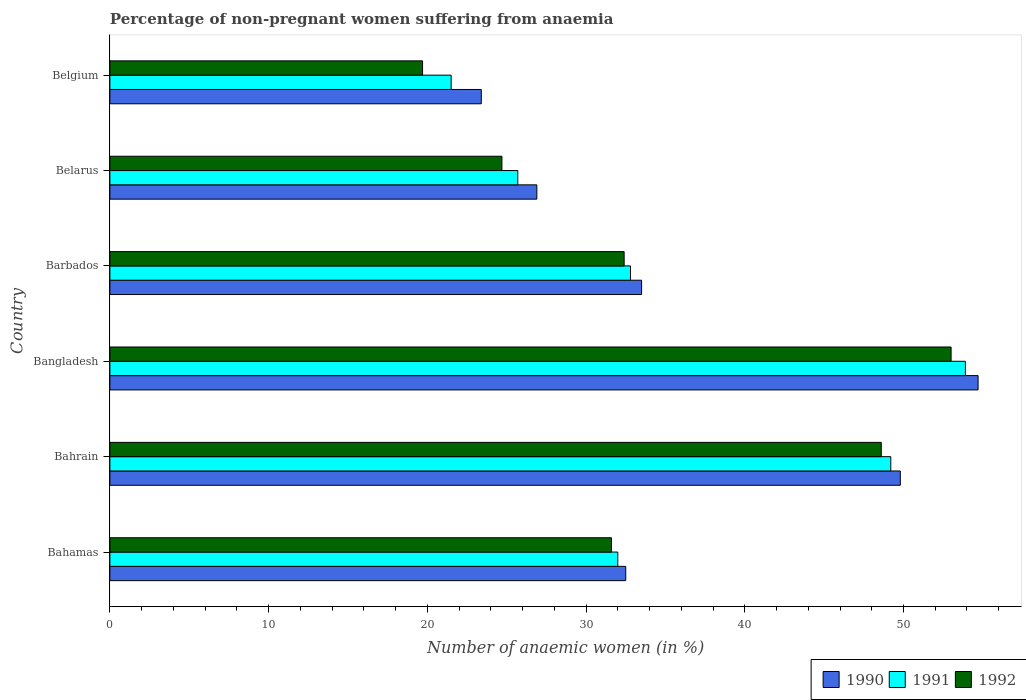How many groups of bars are there?
Keep it short and to the point. 6. Are the number of bars per tick equal to the number of legend labels?
Your response must be concise. Yes. How many bars are there on the 4th tick from the bottom?
Offer a terse response. 3. In how many cases, is the number of bars for a given country not equal to the number of legend labels?
Provide a short and direct response. 0. What is the percentage of non-pregnant women suffering from anaemia in 1990 in Bahamas?
Provide a short and direct response. 32.5. Across all countries, what is the maximum percentage of non-pregnant women suffering from anaemia in 1991?
Give a very brief answer. 53.9. Across all countries, what is the minimum percentage of non-pregnant women suffering from anaemia in 1991?
Make the answer very short. 21.5. In which country was the percentage of non-pregnant women suffering from anaemia in 1990 maximum?
Your answer should be compact. Bangladesh. What is the total percentage of non-pregnant women suffering from anaemia in 1990 in the graph?
Give a very brief answer. 220.8. What is the difference between the percentage of non-pregnant women suffering from anaemia in 1991 in Bahamas and that in Belgium?
Your answer should be very brief. 10.5. What is the average percentage of non-pregnant women suffering from anaemia in 1990 per country?
Give a very brief answer. 36.8. What is the difference between the percentage of non-pregnant women suffering from anaemia in 1992 and percentage of non-pregnant women suffering from anaemia in 1991 in Belgium?
Make the answer very short. -1.8. In how many countries, is the percentage of non-pregnant women suffering from anaemia in 1991 greater than 12 %?
Offer a very short reply. 6. What is the ratio of the percentage of non-pregnant women suffering from anaemia in 1990 in Barbados to that in Belgium?
Give a very brief answer. 1.43. Is the percentage of non-pregnant women suffering from anaemia in 1992 in Bahrain less than that in Belgium?
Offer a very short reply. No. What is the difference between the highest and the second highest percentage of non-pregnant women suffering from anaemia in 1991?
Keep it short and to the point. 4.7. What is the difference between the highest and the lowest percentage of non-pregnant women suffering from anaemia in 1991?
Keep it short and to the point. 32.4. How many countries are there in the graph?
Make the answer very short. 6. What is the difference between two consecutive major ticks on the X-axis?
Keep it short and to the point. 10. Does the graph contain any zero values?
Your answer should be very brief. No. Where does the legend appear in the graph?
Your response must be concise. Bottom right. What is the title of the graph?
Your response must be concise. Percentage of non-pregnant women suffering from anaemia. Does "1994" appear as one of the legend labels in the graph?
Your response must be concise. No. What is the label or title of the X-axis?
Offer a very short reply. Number of anaemic women (in %). What is the Number of anaemic women (in %) of 1990 in Bahamas?
Make the answer very short. 32.5. What is the Number of anaemic women (in %) in 1991 in Bahamas?
Ensure brevity in your answer.  32. What is the Number of anaemic women (in %) of 1992 in Bahamas?
Provide a succinct answer. 31.6. What is the Number of anaemic women (in %) of 1990 in Bahrain?
Offer a terse response. 49.8. What is the Number of anaemic women (in %) of 1991 in Bahrain?
Ensure brevity in your answer.  49.2. What is the Number of anaemic women (in %) of 1992 in Bahrain?
Your response must be concise. 48.6. What is the Number of anaemic women (in %) in 1990 in Bangladesh?
Your response must be concise. 54.7. What is the Number of anaemic women (in %) of 1991 in Bangladesh?
Your answer should be compact. 53.9. What is the Number of anaemic women (in %) in 1990 in Barbados?
Provide a succinct answer. 33.5. What is the Number of anaemic women (in %) in 1991 in Barbados?
Your answer should be very brief. 32.8. What is the Number of anaemic women (in %) of 1992 in Barbados?
Your response must be concise. 32.4. What is the Number of anaemic women (in %) in 1990 in Belarus?
Offer a very short reply. 26.9. What is the Number of anaemic women (in %) of 1991 in Belarus?
Provide a succinct answer. 25.7. What is the Number of anaemic women (in %) in 1992 in Belarus?
Offer a terse response. 24.7. What is the Number of anaemic women (in %) of 1990 in Belgium?
Give a very brief answer. 23.4. What is the Number of anaemic women (in %) in 1991 in Belgium?
Your answer should be compact. 21.5. Across all countries, what is the maximum Number of anaemic women (in %) in 1990?
Offer a terse response. 54.7. Across all countries, what is the maximum Number of anaemic women (in %) of 1991?
Your response must be concise. 53.9. Across all countries, what is the minimum Number of anaemic women (in %) in 1990?
Your answer should be very brief. 23.4. Across all countries, what is the minimum Number of anaemic women (in %) in 1991?
Provide a short and direct response. 21.5. What is the total Number of anaemic women (in %) of 1990 in the graph?
Provide a succinct answer. 220.8. What is the total Number of anaemic women (in %) of 1991 in the graph?
Offer a very short reply. 215.1. What is the total Number of anaemic women (in %) in 1992 in the graph?
Offer a very short reply. 210. What is the difference between the Number of anaemic women (in %) in 1990 in Bahamas and that in Bahrain?
Offer a very short reply. -17.3. What is the difference between the Number of anaemic women (in %) in 1991 in Bahamas and that in Bahrain?
Ensure brevity in your answer.  -17.2. What is the difference between the Number of anaemic women (in %) of 1990 in Bahamas and that in Bangladesh?
Offer a terse response. -22.2. What is the difference between the Number of anaemic women (in %) of 1991 in Bahamas and that in Bangladesh?
Give a very brief answer. -21.9. What is the difference between the Number of anaemic women (in %) in 1992 in Bahamas and that in Bangladesh?
Offer a terse response. -21.4. What is the difference between the Number of anaemic women (in %) in 1990 in Bahamas and that in Barbados?
Give a very brief answer. -1. What is the difference between the Number of anaemic women (in %) in 1992 in Bahamas and that in Barbados?
Your answer should be compact. -0.8. What is the difference between the Number of anaemic women (in %) in 1990 in Bahamas and that in Belgium?
Provide a short and direct response. 9.1. What is the difference between the Number of anaemic women (in %) in 1991 in Bahamas and that in Belgium?
Make the answer very short. 10.5. What is the difference between the Number of anaemic women (in %) in 1990 in Bahrain and that in Bangladesh?
Your response must be concise. -4.9. What is the difference between the Number of anaemic women (in %) of 1991 in Bahrain and that in Bangladesh?
Keep it short and to the point. -4.7. What is the difference between the Number of anaemic women (in %) of 1992 in Bahrain and that in Bangladesh?
Give a very brief answer. -4.4. What is the difference between the Number of anaemic women (in %) in 1990 in Bahrain and that in Belarus?
Ensure brevity in your answer.  22.9. What is the difference between the Number of anaemic women (in %) of 1992 in Bahrain and that in Belarus?
Provide a succinct answer. 23.9. What is the difference between the Number of anaemic women (in %) of 1990 in Bahrain and that in Belgium?
Ensure brevity in your answer.  26.4. What is the difference between the Number of anaemic women (in %) in 1991 in Bahrain and that in Belgium?
Provide a succinct answer. 27.7. What is the difference between the Number of anaemic women (in %) in 1992 in Bahrain and that in Belgium?
Give a very brief answer. 28.9. What is the difference between the Number of anaemic women (in %) in 1990 in Bangladesh and that in Barbados?
Offer a very short reply. 21.2. What is the difference between the Number of anaemic women (in %) in 1991 in Bangladesh and that in Barbados?
Offer a terse response. 21.1. What is the difference between the Number of anaemic women (in %) in 1992 in Bangladesh and that in Barbados?
Provide a succinct answer. 20.6. What is the difference between the Number of anaemic women (in %) of 1990 in Bangladesh and that in Belarus?
Offer a very short reply. 27.8. What is the difference between the Number of anaemic women (in %) of 1991 in Bangladesh and that in Belarus?
Ensure brevity in your answer.  28.2. What is the difference between the Number of anaemic women (in %) in 1992 in Bangladesh and that in Belarus?
Make the answer very short. 28.3. What is the difference between the Number of anaemic women (in %) of 1990 in Bangladesh and that in Belgium?
Keep it short and to the point. 31.3. What is the difference between the Number of anaemic women (in %) in 1991 in Bangladesh and that in Belgium?
Your answer should be compact. 32.4. What is the difference between the Number of anaemic women (in %) in 1992 in Bangladesh and that in Belgium?
Keep it short and to the point. 33.3. What is the difference between the Number of anaemic women (in %) of 1990 in Barbados and that in Belarus?
Your answer should be compact. 6.6. What is the difference between the Number of anaemic women (in %) in 1992 in Barbados and that in Belarus?
Your response must be concise. 7.7. What is the difference between the Number of anaemic women (in %) of 1990 in Belarus and that in Belgium?
Offer a very short reply. 3.5. What is the difference between the Number of anaemic women (in %) of 1991 in Belarus and that in Belgium?
Make the answer very short. 4.2. What is the difference between the Number of anaemic women (in %) in 1990 in Bahamas and the Number of anaemic women (in %) in 1991 in Bahrain?
Your answer should be compact. -16.7. What is the difference between the Number of anaemic women (in %) of 1990 in Bahamas and the Number of anaemic women (in %) of 1992 in Bahrain?
Ensure brevity in your answer.  -16.1. What is the difference between the Number of anaemic women (in %) of 1991 in Bahamas and the Number of anaemic women (in %) of 1992 in Bahrain?
Your answer should be very brief. -16.6. What is the difference between the Number of anaemic women (in %) of 1990 in Bahamas and the Number of anaemic women (in %) of 1991 in Bangladesh?
Keep it short and to the point. -21.4. What is the difference between the Number of anaemic women (in %) in 1990 in Bahamas and the Number of anaemic women (in %) in 1992 in Bangladesh?
Offer a terse response. -20.5. What is the difference between the Number of anaemic women (in %) of 1991 in Bahamas and the Number of anaemic women (in %) of 1992 in Bangladesh?
Make the answer very short. -21. What is the difference between the Number of anaemic women (in %) of 1990 in Bahamas and the Number of anaemic women (in %) of 1991 in Barbados?
Offer a very short reply. -0.3. What is the difference between the Number of anaemic women (in %) in 1990 in Bahamas and the Number of anaemic women (in %) in 1992 in Barbados?
Your answer should be very brief. 0.1. What is the difference between the Number of anaemic women (in %) of 1991 in Bahamas and the Number of anaemic women (in %) of 1992 in Barbados?
Your answer should be very brief. -0.4. What is the difference between the Number of anaemic women (in %) of 1990 in Bahamas and the Number of anaemic women (in %) of 1991 in Belarus?
Your answer should be very brief. 6.8. What is the difference between the Number of anaemic women (in %) of 1991 in Bahamas and the Number of anaemic women (in %) of 1992 in Belarus?
Make the answer very short. 7.3. What is the difference between the Number of anaemic women (in %) in 1990 in Bahamas and the Number of anaemic women (in %) in 1991 in Belgium?
Your answer should be very brief. 11. What is the difference between the Number of anaemic women (in %) in 1991 in Bahamas and the Number of anaemic women (in %) in 1992 in Belgium?
Provide a short and direct response. 12.3. What is the difference between the Number of anaemic women (in %) of 1990 in Bahrain and the Number of anaemic women (in %) of 1991 in Barbados?
Offer a terse response. 17. What is the difference between the Number of anaemic women (in %) in 1991 in Bahrain and the Number of anaemic women (in %) in 1992 in Barbados?
Ensure brevity in your answer.  16.8. What is the difference between the Number of anaemic women (in %) of 1990 in Bahrain and the Number of anaemic women (in %) of 1991 in Belarus?
Make the answer very short. 24.1. What is the difference between the Number of anaemic women (in %) of 1990 in Bahrain and the Number of anaemic women (in %) of 1992 in Belarus?
Keep it short and to the point. 25.1. What is the difference between the Number of anaemic women (in %) in 1991 in Bahrain and the Number of anaemic women (in %) in 1992 in Belarus?
Offer a terse response. 24.5. What is the difference between the Number of anaemic women (in %) of 1990 in Bahrain and the Number of anaemic women (in %) of 1991 in Belgium?
Keep it short and to the point. 28.3. What is the difference between the Number of anaemic women (in %) of 1990 in Bahrain and the Number of anaemic women (in %) of 1992 in Belgium?
Make the answer very short. 30.1. What is the difference between the Number of anaemic women (in %) of 1991 in Bahrain and the Number of anaemic women (in %) of 1992 in Belgium?
Keep it short and to the point. 29.5. What is the difference between the Number of anaemic women (in %) of 1990 in Bangladesh and the Number of anaemic women (in %) of 1991 in Barbados?
Your answer should be very brief. 21.9. What is the difference between the Number of anaemic women (in %) of 1990 in Bangladesh and the Number of anaemic women (in %) of 1992 in Barbados?
Your answer should be very brief. 22.3. What is the difference between the Number of anaemic women (in %) of 1991 in Bangladesh and the Number of anaemic women (in %) of 1992 in Barbados?
Your response must be concise. 21.5. What is the difference between the Number of anaemic women (in %) of 1990 in Bangladesh and the Number of anaemic women (in %) of 1992 in Belarus?
Make the answer very short. 30. What is the difference between the Number of anaemic women (in %) of 1991 in Bangladesh and the Number of anaemic women (in %) of 1992 in Belarus?
Make the answer very short. 29.2. What is the difference between the Number of anaemic women (in %) in 1990 in Bangladesh and the Number of anaemic women (in %) in 1991 in Belgium?
Provide a short and direct response. 33.2. What is the difference between the Number of anaemic women (in %) in 1991 in Bangladesh and the Number of anaemic women (in %) in 1992 in Belgium?
Offer a very short reply. 34.2. What is the difference between the Number of anaemic women (in %) of 1990 in Barbados and the Number of anaemic women (in %) of 1991 in Belarus?
Provide a succinct answer. 7.8. What is the difference between the Number of anaemic women (in %) of 1991 in Barbados and the Number of anaemic women (in %) of 1992 in Belarus?
Ensure brevity in your answer.  8.1. What is the difference between the Number of anaemic women (in %) of 1990 in Belarus and the Number of anaemic women (in %) of 1991 in Belgium?
Provide a succinct answer. 5.4. What is the difference between the Number of anaemic women (in %) of 1990 in Belarus and the Number of anaemic women (in %) of 1992 in Belgium?
Offer a terse response. 7.2. What is the difference between the Number of anaemic women (in %) of 1991 in Belarus and the Number of anaemic women (in %) of 1992 in Belgium?
Your response must be concise. 6. What is the average Number of anaemic women (in %) of 1990 per country?
Offer a very short reply. 36.8. What is the average Number of anaemic women (in %) in 1991 per country?
Your answer should be compact. 35.85. What is the difference between the Number of anaemic women (in %) in 1990 and Number of anaemic women (in %) in 1991 in Bangladesh?
Your response must be concise. 0.8. What is the difference between the Number of anaemic women (in %) of 1991 and Number of anaemic women (in %) of 1992 in Bangladesh?
Ensure brevity in your answer.  0.9. What is the difference between the Number of anaemic women (in %) in 1990 and Number of anaemic women (in %) in 1991 in Barbados?
Your response must be concise. 0.7. What is the difference between the Number of anaemic women (in %) of 1991 and Number of anaemic women (in %) of 1992 in Barbados?
Provide a short and direct response. 0.4. What is the difference between the Number of anaemic women (in %) of 1990 and Number of anaemic women (in %) of 1992 in Belarus?
Give a very brief answer. 2.2. What is the difference between the Number of anaemic women (in %) in 1991 and Number of anaemic women (in %) in 1992 in Belarus?
Make the answer very short. 1. What is the ratio of the Number of anaemic women (in %) in 1990 in Bahamas to that in Bahrain?
Provide a succinct answer. 0.65. What is the ratio of the Number of anaemic women (in %) of 1991 in Bahamas to that in Bahrain?
Ensure brevity in your answer.  0.65. What is the ratio of the Number of anaemic women (in %) in 1992 in Bahamas to that in Bahrain?
Offer a terse response. 0.65. What is the ratio of the Number of anaemic women (in %) of 1990 in Bahamas to that in Bangladesh?
Provide a succinct answer. 0.59. What is the ratio of the Number of anaemic women (in %) of 1991 in Bahamas to that in Bangladesh?
Give a very brief answer. 0.59. What is the ratio of the Number of anaemic women (in %) of 1992 in Bahamas to that in Bangladesh?
Give a very brief answer. 0.6. What is the ratio of the Number of anaemic women (in %) of 1990 in Bahamas to that in Barbados?
Offer a very short reply. 0.97. What is the ratio of the Number of anaemic women (in %) of 1991 in Bahamas to that in Barbados?
Your answer should be very brief. 0.98. What is the ratio of the Number of anaemic women (in %) in 1992 in Bahamas to that in Barbados?
Give a very brief answer. 0.98. What is the ratio of the Number of anaemic women (in %) of 1990 in Bahamas to that in Belarus?
Provide a succinct answer. 1.21. What is the ratio of the Number of anaemic women (in %) in 1991 in Bahamas to that in Belarus?
Your response must be concise. 1.25. What is the ratio of the Number of anaemic women (in %) of 1992 in Bahamas to that in Belarus?
Keep it short and to the point. 1.28. What is the ratio of the Number of anaemic women (in %) in 1990 in Bahamas to that in Belgium?
Provide a short and direct response. 1.39. What is the ratio of the Number of anaemic women (in %) of 1991 in Bahamas to that in Belgium?
Keep it short and to the point. 1.49. What is the ratio of the Number of anaemic women (in %) of 1992 in Bahamas to that in Belgium?
Provide a succinct answer. 1.6. What is the ratio of the Number of anaemic women (in %) of 1990 in Bahrain to that in Bangladesh?
Offer a very short reply. 0.91. What is the ratio of the Number of anaemic women (in %) in 1991 in Bahrain to that in Bangladesh?
Your response must be concise. 0.91. What is the ratio of the Number of anaemic women (in %) of 1992 in Bahrain to that in Bangladesh?
Your answer should be compact. 0.92. What is the ratio of the Number of anaemic women (in %) in 1990 in Bahrain to that in Barbados?
Your answer should be compact. 1.49. What is the ratio of the Number of anaemic women (in %) in 1990 in Bahrain to that in Belarus?
Give a very brief answer. 1.85. What is the ratio of the Number of anaemic women (in %) of 1991 in Bahrain to that in Belarus?
Offer a very short reply. 1.91. What is the ratio of the Number of anaemic women (in %) in 1992 in Bahrain to that in Belarus?
Make the answer very short. 1.97. What is the ratio of the Number of anaemic women (in %) in 1990 in Bahrain to that in Belgium?
Ensure brevity in your answer.  2.13. What is the ratio of the Number of anaemic women (in %) in 1991 in Bahrain to that in Belgium?
Provide a short and direct response. 2.29. What is the ratio of the Number of anaemic women (in %) of 1992 in Bahrain to that in Belgium?
Provide a short and direct response. 2.47. What is the ratio of the Number of anaemic women (in %) of 1990 in Bangladesh to that in Barbados?
Make the answer very short. 1.63. What is the ratio of the Number of anaemic women (in %) in 1991 in Bangladesh to that in Barbados?
Your answer should be very brief. 1.64. What is the ratio of the Number of anaemic women (in %) of 1992 in Bangladesh to that in Barbados?
Provide a succinct answer. 1.64. What is the ratio of the Number of anaemic women (in %) in 1990 in Bangladesh to that in Belarus?
Your response must be concise. 2.03. What is the ratio of the Number of anaemic women (in %) of 1991 in Bangladesh to that in Belarus?
Offer a terse response. 2.1. What is the ratio of the Number of anaemic women (in %) in 1992 in Bangladesh to that in Belarus?
Your answer should be very brief. 2.15. What is the ratio of the Number of anaemic women (in %) of 1990 in Bangladesh to that in Belgium?
Make the answer very short. 2.34. What is the ratio of the Number of anaemic women (in %) of 1991 in Bangladesh to that in Belgium?
Give a very brief answer. 2.51. What is the ratio of the Number of anaemic women (in %) in 1992 in Bangladesh to that in Belgium?
Your response must be concise. 2.69. What is the ratio of the Number of anaemic women (in %) of 1990 in Barbados to that in Belarus?
Your response must be concise. 1.25. What is the ratio of the Number of anaemic women (in %) of 1991 in Barbados to that in Belarus?
Your response must be concise. 1.28. What is the ratio of the Number of anaemic women (in %) in 1992 in Barbados to that in Belarus?
Ensure brevity in your answer.  1.31. What is the ratio of the Number of anaemic women (in %) of 1990 in Barbados to that in Belgium?
Provide a short and direct response. 1.43. What is the ratio of the Number of anaemic women (in %) in 1991 in Barbados to that in Belgium?
Keep it short and to the point. 1.53. What is the ratio of the Number of anaemic women (in %) of 1992 in Barbados to that in Belgium?
Give a very brief answer. 1.64. What is the ratio of the Number of anaemic women (in %) of 1990 in Belarus to that in Belgium?
Keep it short and to the point. 1.15. What is the ratio of the Number of anaemic women (in %) of 1991 in Belarus to that in Belgium?
Your answer should be very brief. 1.2. What is the ratio of the Number of anaemic women (in %) in 1992 in Belarus to that in Belgium?
Offer a terse response. 1.25. What is the difference between the highest and the second highest Number of anaemic women (in %) in 1991?
Your response must be concise. 4.7. What is the difference between the highest and the lowest Number of anaemic women (in %) in 1990?
Give a very brief answer. 31.3. What is the difference between the highest and the lowest Number of anaemic women (in %) in 1991?
Provide a succinct answer. 32.4. What is the difference between the highest and the lowest Number of anaemic women (in %) in 1992?
Keep it short and to the point. 33.3. 